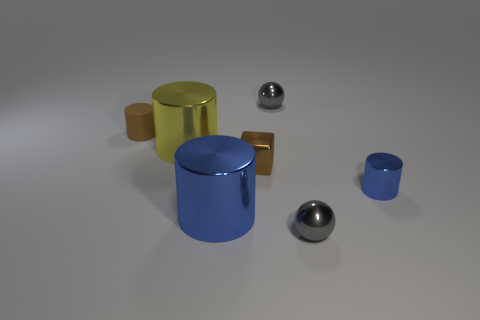There is another cylinder that is the same color as the tiny shiny cylinder; what size is it?
Ensure brevity in your answer.  Large. What number of cylinders have the same color as the block?
Ensure brevity in your answer.  1. There is a object that is the same color as the rubber cylinder; what is it made of?
Ensure brevity in your answer.  Metal. There is another yellow object that is the same shape as the rubber thing; what is its size?
Your response must be concise. Large. Is the size of the shiny cube the same as the yellow thing?
Keep it short and to the point. No. What color is the matte thing that is the same shape as the yellow shiny thing?
Keep it short and to the point. Brown. How big is the object that is both to the right of the large blue cylinder and in front of the small blue thing?
Give a very brief answer. Small. There is a tiny cylinder on the right side of the brown thing in front of the yellow metallic thing; how many brown metal objects are to the left of it?
Offer a very short reply. 1. What number of small objects are blocks or gray rubber spheres?
Provide a short and direct response. 1. Is the small brown thing that is on the right side of the tiny matte object made of the same material as the small blue thing?
Keep it short and to the point. Yes. 